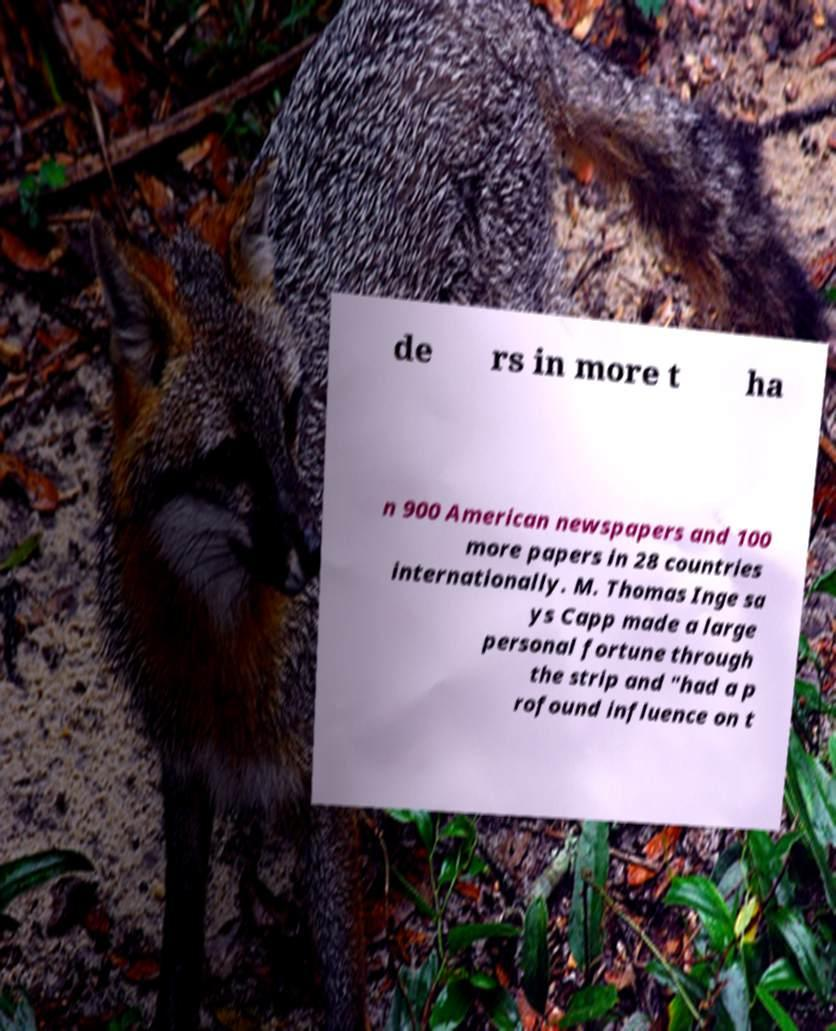What messages or text are displayed in this image? I need them in a readable, typed format. de rs in more t ha n 900 American newspapers and 100 more papers in 28 countries internationally. M. Thomas Inge sa ys Capp made a large personal fortune through the strip and "had a p rofound influence on t 